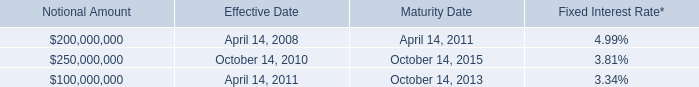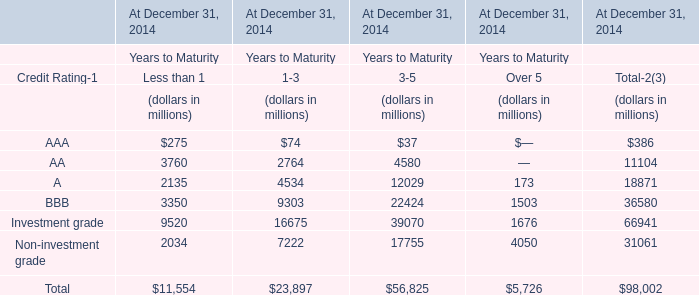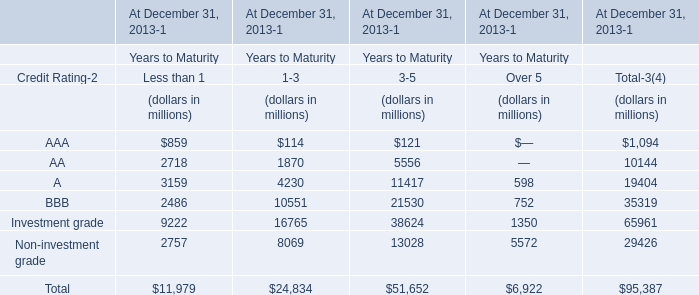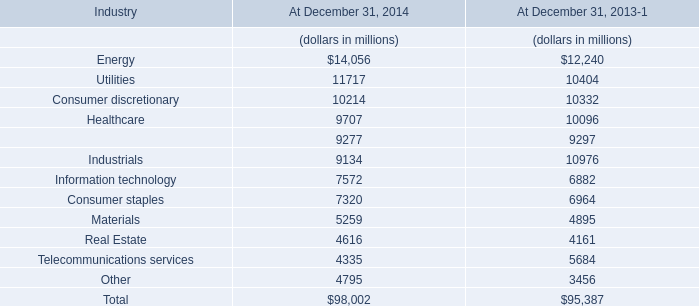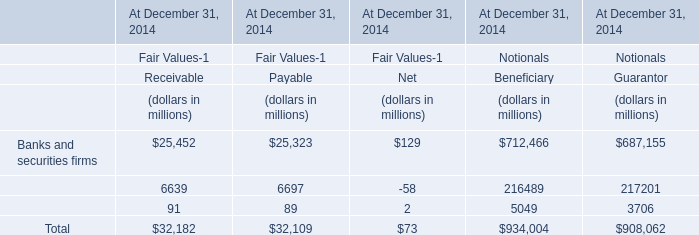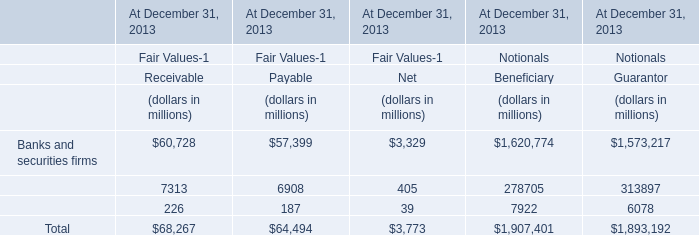What was the total amount of elements greater than 2000 for Less than 1 ? (in million) 
Computations: (((2718 + 3159) + 2486) + 2757)
Answer: 11120.0. 